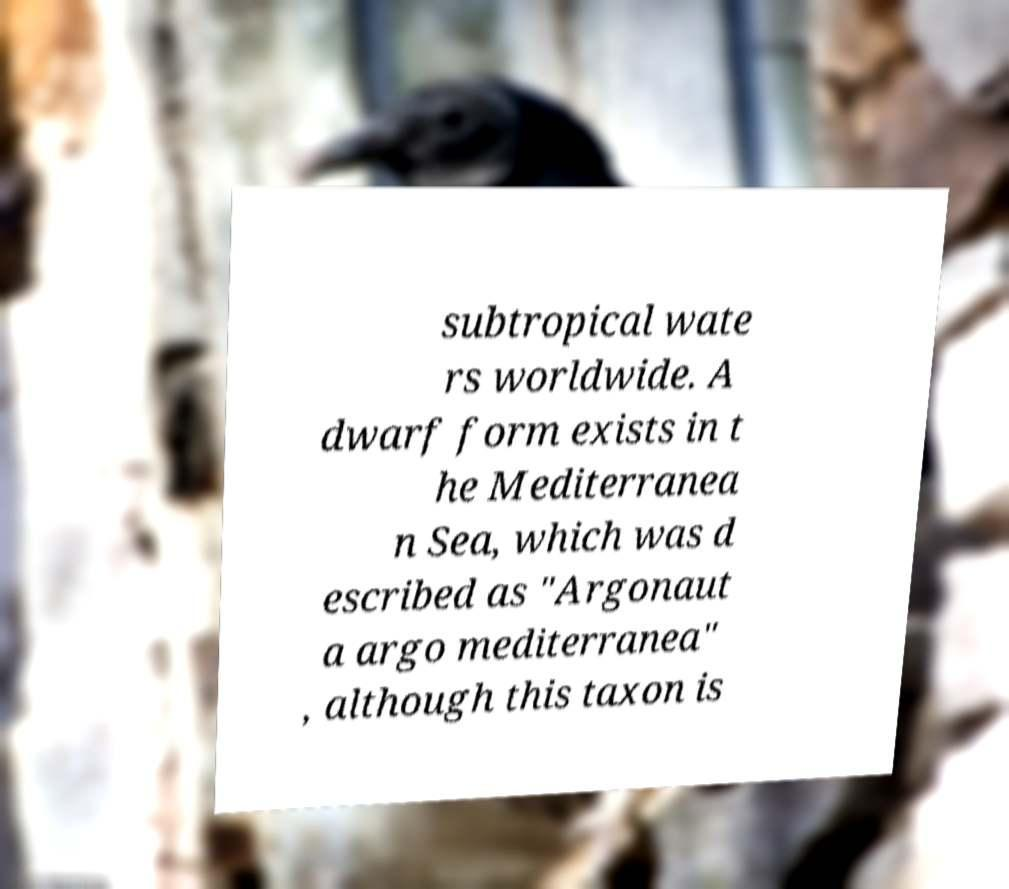Please identify and transcribe the text found in this image. subtropical wate rs worldwide. A dwarf form exists in t he Mediterranea n Sea, which was d escribed as "Argonaut a argo mediterranea" , although this taxon is 